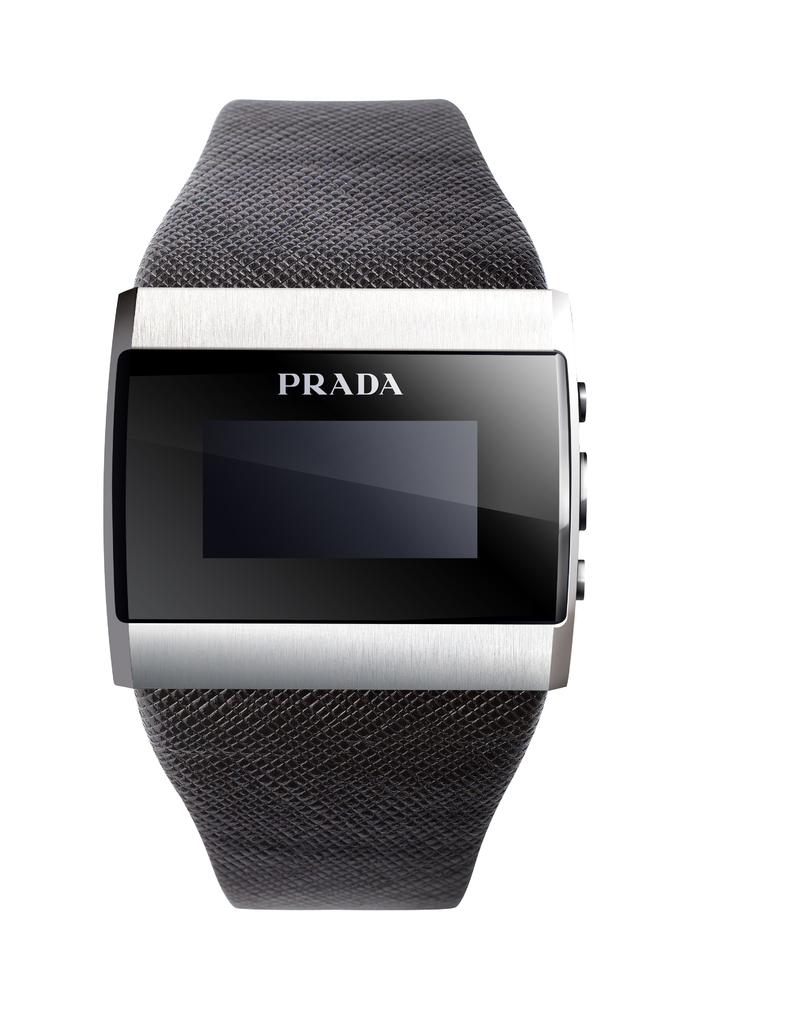<image>
Render a clear and concise summary of the photo. A smart looking watch with the word Prada on the top 